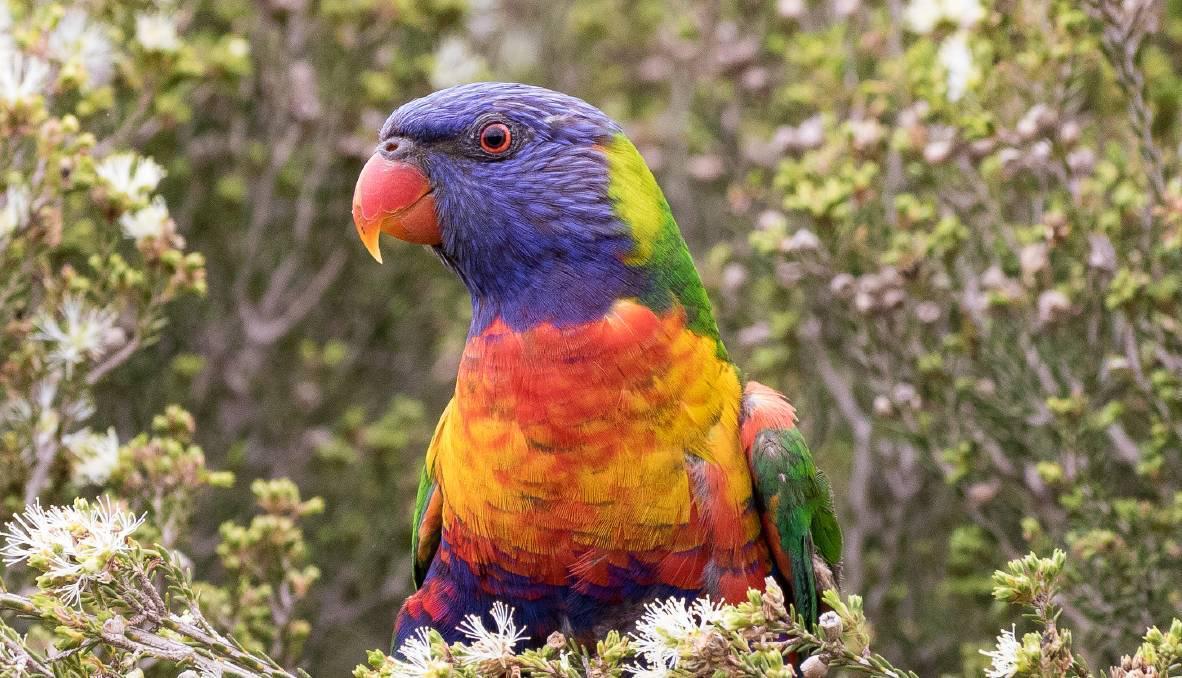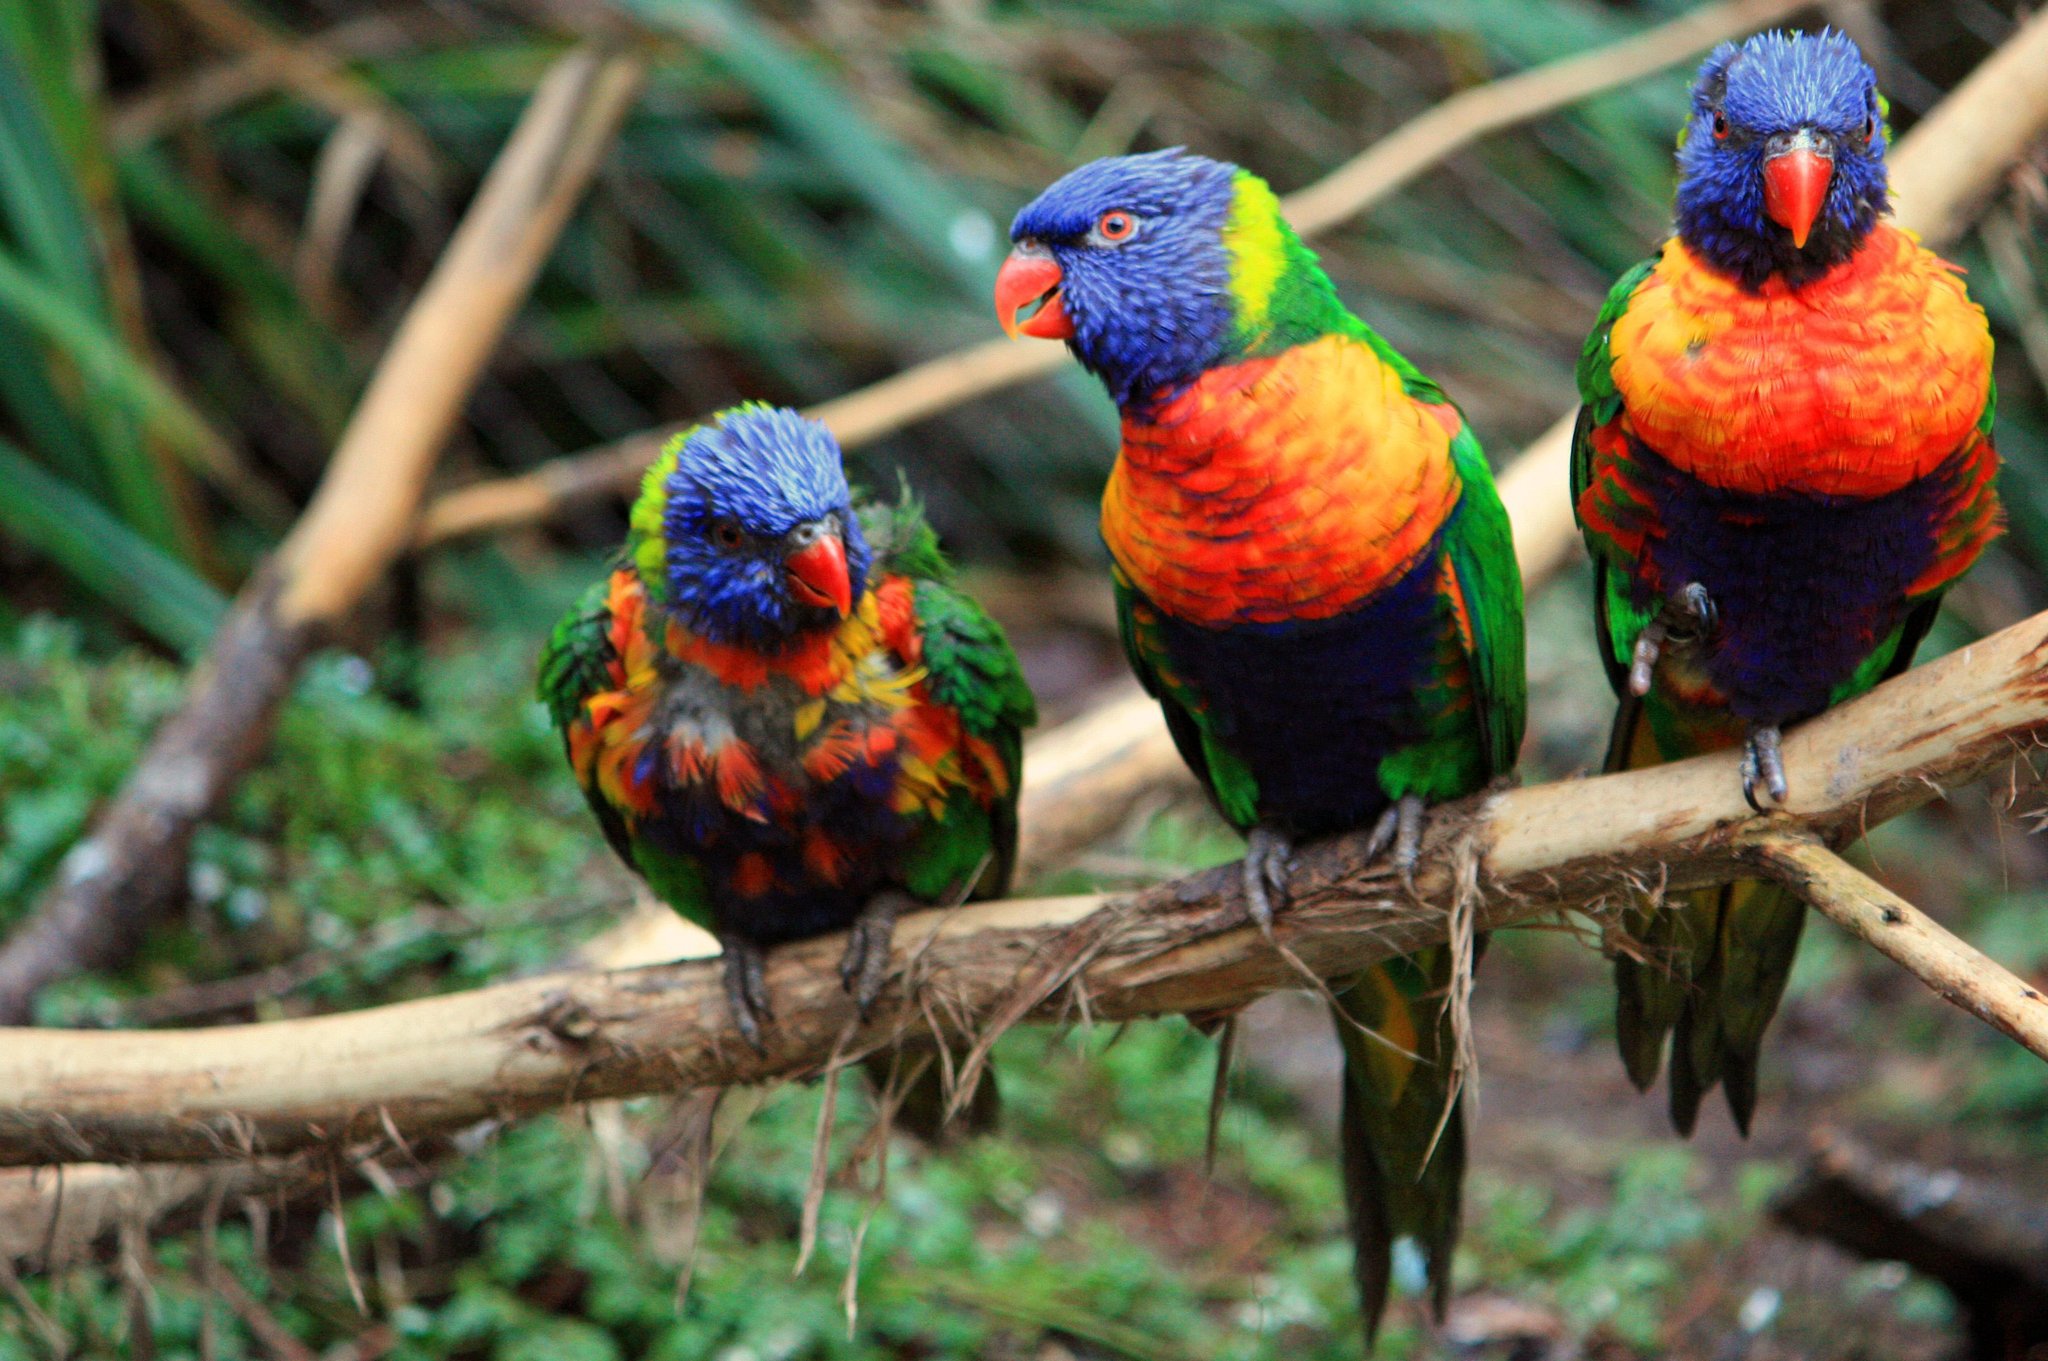The first image is the image on the left, the second image is the image on the right. Examine the images to the left and right. Is the description "there are 4 parrots in the image pair" accurate? Answer yes or no. Yes. The first image is the image on the left, the second image is the image on the right. Considering the images on both sides, is "There are four parrots." valid? Answer yes or no. Yes. 